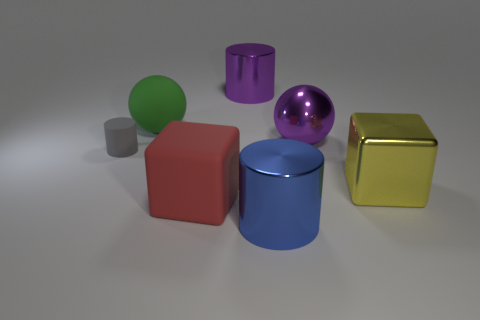Is the color of the metallic cylinder that is behind the small rubber cylinder the same as the big metallic sphere?
Your response must be concise. Yes. Is there a metallic cylinder of the same color as the large metal ball?
Offer a very short reply. Yes. Do the rubber thing that is in front of the gray thing and the yellow thing have the same size?
Your answer should be compact. Yes. Are there fewer large purple metallic objects than matte things?
Give a very brief answer. Yes. What is the shape of the purple metal thing that is on the right side of the cylinder that is in front of the large block right of the red object?
Make the answer very short. Sphere. Are there any small cylinders that have the same material as the purple ball?
Provide a short and direct response. No. Do the shiny cylinder that is behind the yellow cube and the sphere that is to the right of the large blue cylinder have the same color?
Your response must be concise. Yes. Are there fewer blue shiny objects that are behind the large rubber block than blue metal cylinders?
Keep it short and to the point. Yes. What number of objects are big blue metallic cylinders or rubber objects that are on the right side of the small cylinder?
Make the answer very short. 3. There is a big block that is made of the same material as the small gray cylinder; what color is it?
Keep it short and to the point. Red. 